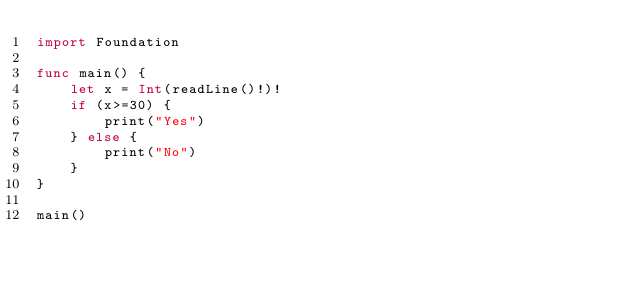<code> <loc_0><loc_0><loc_500><loc_500><_Swift_>import Foundation

func main() {
    let x = Int(readLine()!)!
    if (x>=30) {
        print("Yes")
    } else {
        print("No")
    }
}

main()</code> 